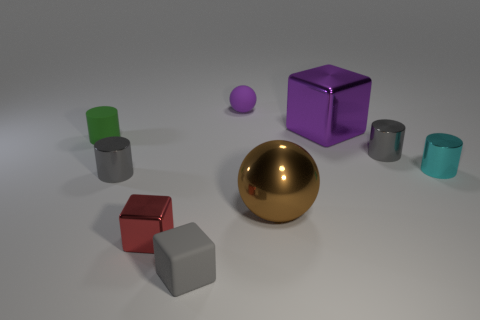Subtract all red shiny blocks. How many blocks are left? 2 Subtract all brown spheres. How many gray cylinders are left? 2 Subtract all red blocks. How many blocks are left? 2 Subtract all cubes. How many objects are left? 6 Subtract 2 cylinders. How many cylinders are left? 2 Subtract all purple cylinders. Subtract all red balls. How many cylinders are left? 4 Add 6 small shiny things. How many small shiny things are left? 10 Add 3 large brown objects. How many large brown objects exist? 4 Subtract 1 gray blocks. How many objects are left? 8 Subtract all metallic cylinders. Subtract all gray metallic cylinders. How many objects are left? 4 